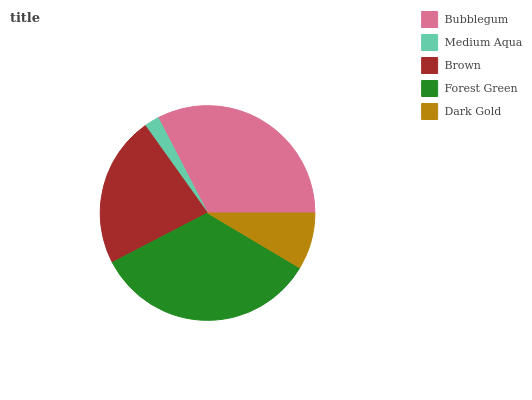Is Medium Aqua the minimum?
Answer yes or no. Yes. Is Forest Green the maximum?
Answer yes or no. Yes. Is Brown the minimum?
Answer yes or no. No. Is Brown the maximum?
Answer yes or no. No. Is Brown greater than Medium Aqua?
Answer yes or no. Yes. Is Medium Aqua less than Brown?
Answer yes or no. Yes. Is Medium Aqua greater than Brown?
Answer yes or no. No. Is Brown less than Medium Aqua?
Answer yes or no. No. Is Brown the high median?
Answer yes or no. Yes. Is Brown the low median?
Answer yes or no. Yes. Is Bubblegum the high median?
Answer yes or no. No. Is Medium Aqua the low median?
Answer yes or no. No. 